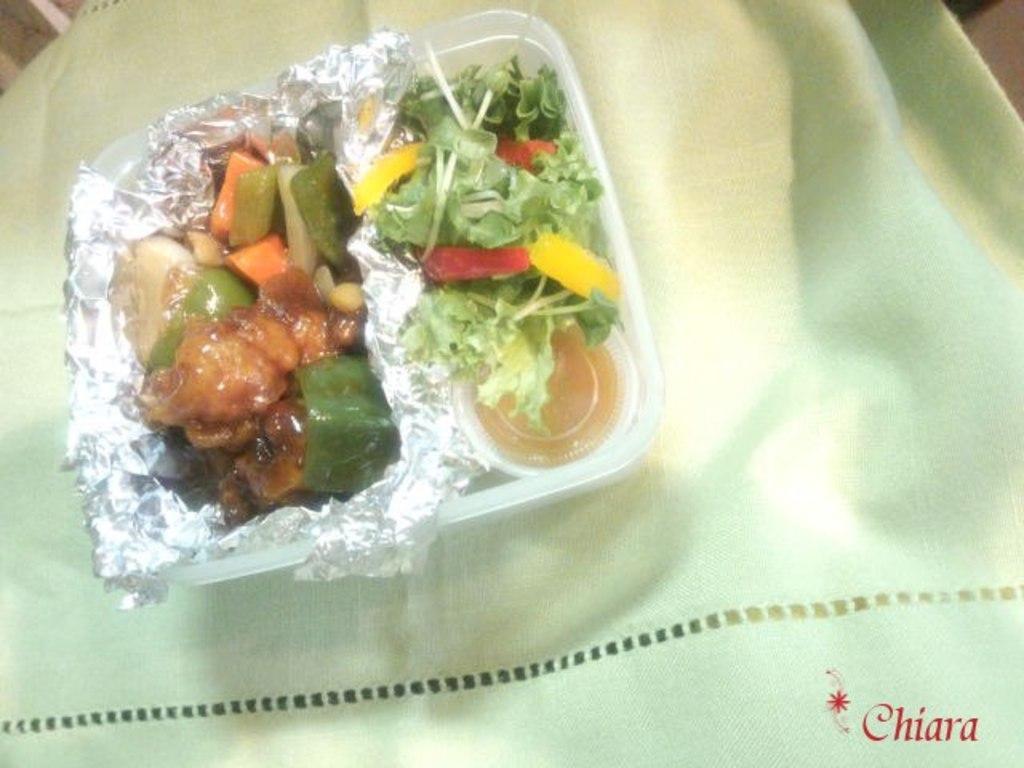In one or two sentences, can you explain what this image depicts? In this image, we can see food in the box and at the bottom, there is a cloth and we can see some text. 